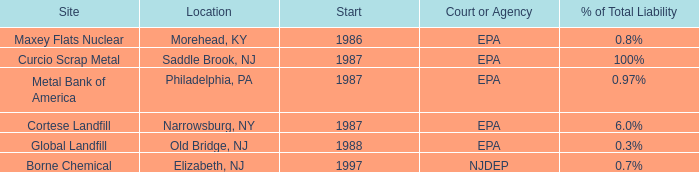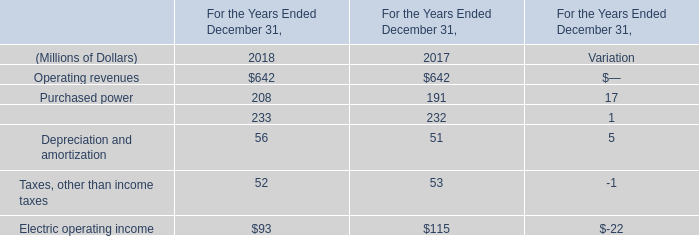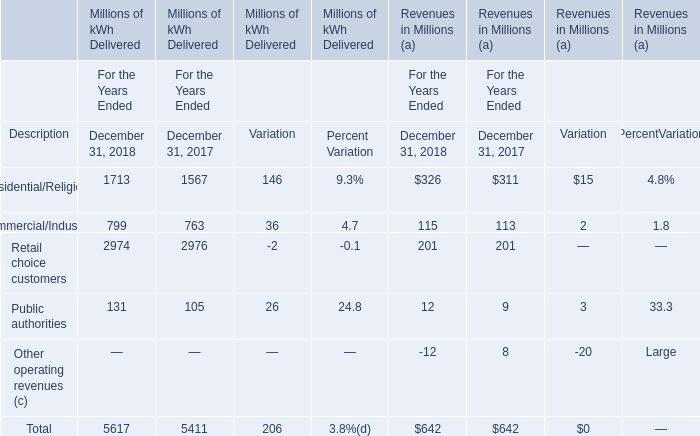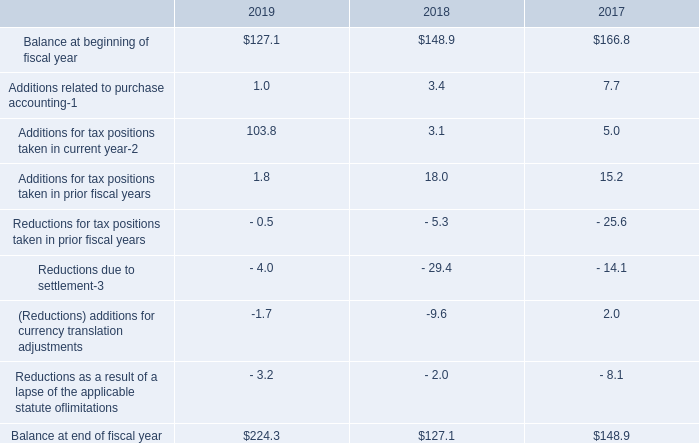Is the total amount of all elements in December 31, 2018 for Millions of kWh Delivered greater than that in December 31, 2017 for Millions of kWh Delivered greater? 
Answer: yes. 